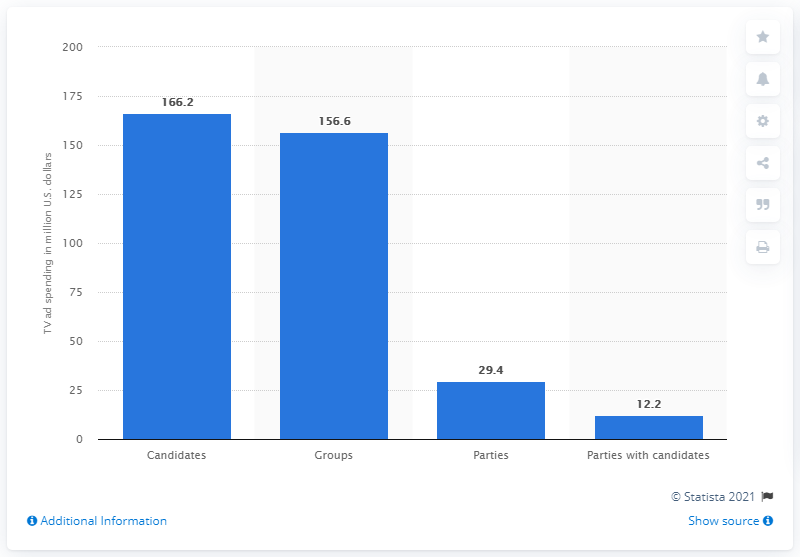Point out several critical features in this image. The amount spent on television advertisements by candidates in the 2014 midterm elections was 166.2. 